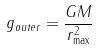Convert formula to latex. <formula><loc_0><loc_0><loc_500><loc_500>g _ { o u t e r } = \frac { G M } { r _ { \max } ^ { 2 } }</formula> 